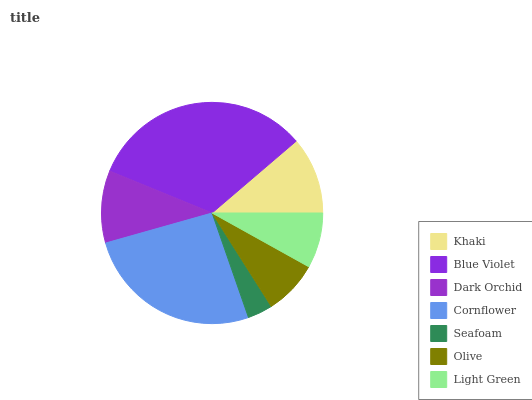Is Seafoam the minimum?
Answer yes or no. Yes. Is Blue Violet the maximum?
Answer yes or no. Yes. Is Dark Orchid the minimum?
Answer yes or no. No. Is Dark Orchid the maximum?
Answer yes or no. No. Is Blue Violet greater than Dark Orchid?
Answer yes or no. Yes. Is Dark Orchid less than Blue Violet?
Answer yes or no. Yes. Is Dark Orchid greater than Blue Violet?
Answer yes or no. No. Is Blue Violet less than Dark Orchid?
Answer yes or no. No. Is Dark Orchid the high median?
Answer yes or no. Yes. Is Dark Orchid the low median?
Answer yes or no. Yes. Is Blue Violet the high median?
Answer yes or no. No. Is Blue Violet the low median?
Answer yes or no. No. 